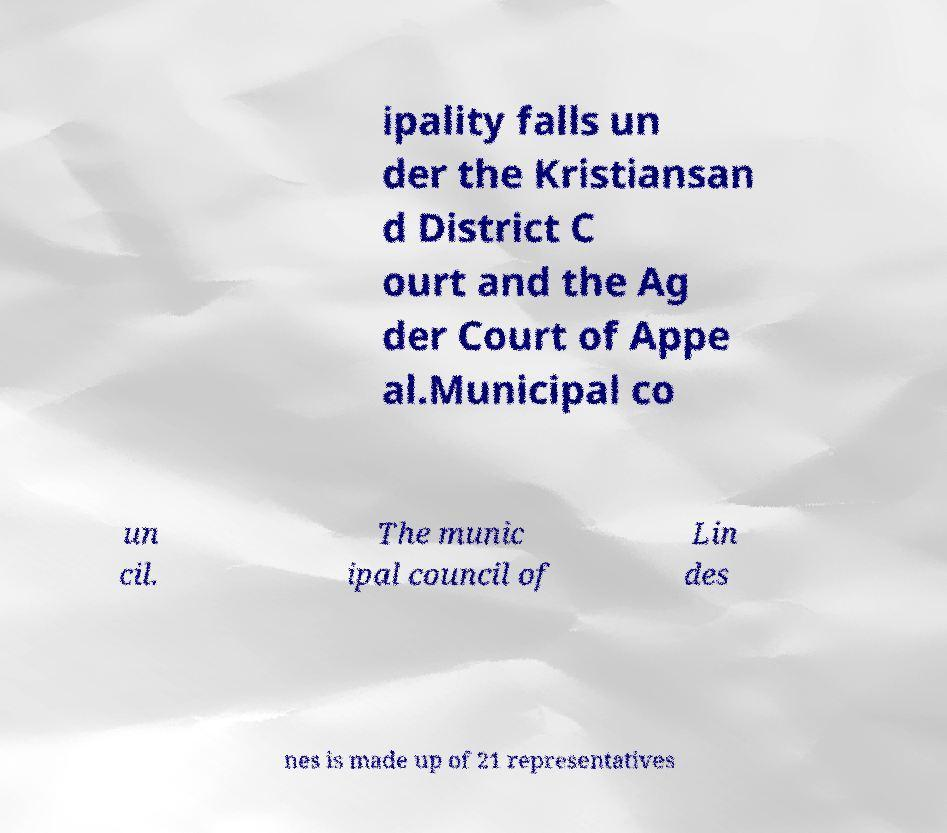Could you assist in decoding the text presented in this image and type it out clearly? ipality falls un der the Kristiansan d District C ourt and the Ag der Court of Appe al.Municipal co un cil. The munic ipal council of Lin des nes is made up of 21 representatives 